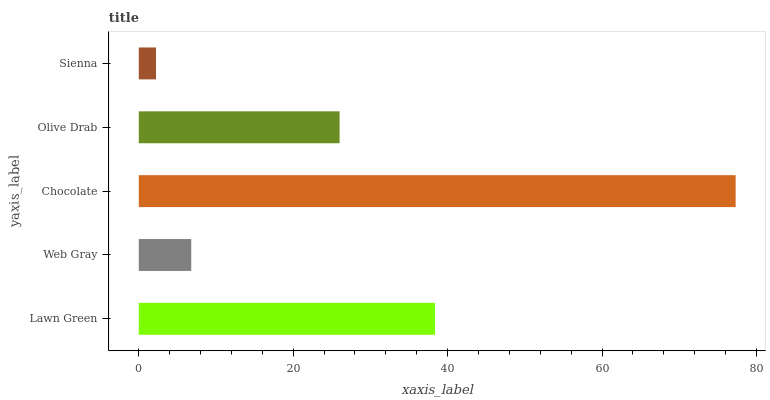Is Sienna the minimum?
Answer yes or no. Yes. Is Chocolate the maximum?
Answer yes or no. Yes. Is Web Gray the minimum?
Answer yes or no. No. Is Web Gray the maximum?
Answer yes or no. No. Is Lawn Green greater than Web Gray?
Answer yes or no. Yes. Is Web Gray less than Lawn Green?
Answer yes or no. Yes. Is Web Gray greater than Lawn Green?
Answer yes or no. No. Is Lawn Green less than Web Gray?
Answer yes or no. No. Is Olive Drab the high median?
Answer yes or no. Yes. Is Olive Drab the low median?
Answer yes or no. Yes. Is Web Gray the high median?
Answer yes or no. No. Is Web Gray the low median?
Answer yes or no. No. 